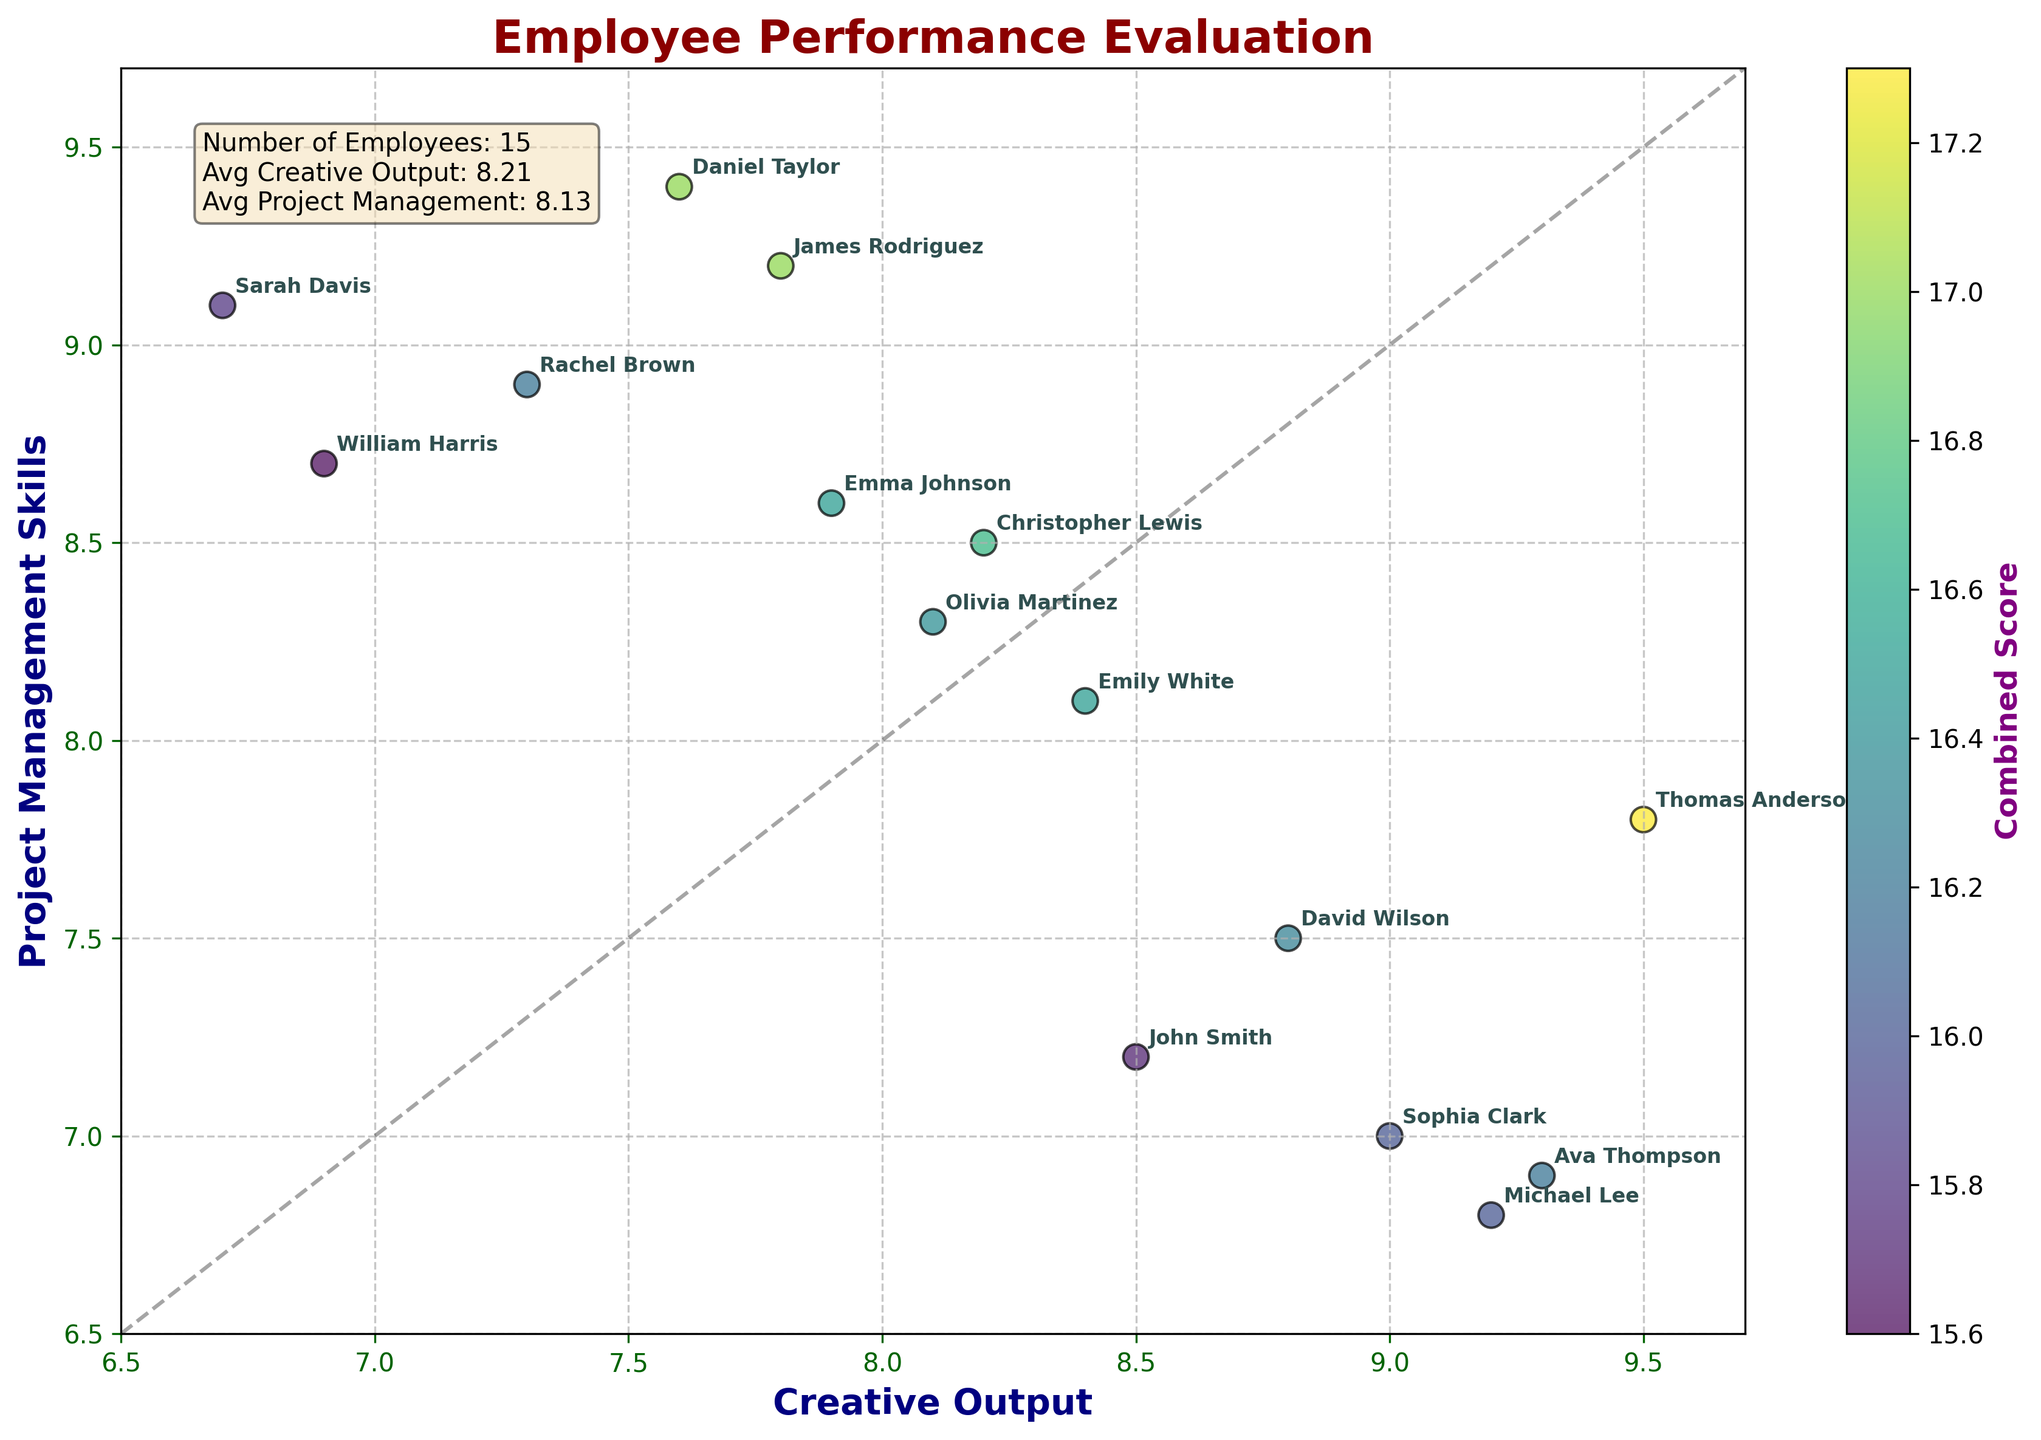What's the title of the figure? The title is usually located at the top of the figure and displayed prominently. In this case, the title reads "Employee Performance Evaluation".
Answer: Employee Performance Evaluation What are the x and y-axis labels? The x-axis label is typically at the bottom, and the y-axis label is along the side of the plot. Here, the x-axis label is "Creative Output" and the y-axis label is "Project Management Skills".
Answer: Creative Output, Project Management Skills How many employees are evaluated in the plot? The number of employees can be determined by counting the unique data points. The statistics text box confirms this number as 15.
Answer: 15 Which employee has the highest creative output but a relatively lower project management score? Look for the point farthest to the right but not too high on the y-axis. Thomas Anderson has the highest creative output (9.5) and a project management score of 7.8.
Answer: Thomas Anderson What is the average creative output score? Refer to the statistics text box on the plot. The average creative output score is provided as 8.18.
Answer: 8.18 Which two employees have the most similar balanced scores of creative output and project management skills? Balance can be judged by proximity to the diagonal line y = x. Rachel Brown and James Rodriguez have very similar scores near the line with values (7.3, 8.9) and (7.8, 9.2), respectively.
Answer: Rachel Brown and James Rodriguez Who has the highest project management skills but relatively lower creative output? Look for the point highest up on the y-axis but not too far right on the x-axis. Daniel Taylor has the highest project management skill (9.4) with a lower creative output score (7.6).
Answer: Daniel Taylor What is the combined score for Olivia Martinez? The combined score can be determined by adding her creative output (8.1) and project management skills (8.3), which equals 16.4.
Answer: 16.4 Between which range does the majority of the creative output scores fall? Visually estimate the range of most data points along the x-axis. Most data points fall between 7.0 and 9.0 on the x-axis.
Answer: 7.0 to 9.0 Who are the top three employees in terms of combined scores? Calculate and compare the combined scores. The top three employees are Thomas Anderson (17.3), Olivia Martinez (16.4), and Emma Johnson (16.5).
Answer: Thomas Anderson, Olivia Martinez, Emma Johnson 